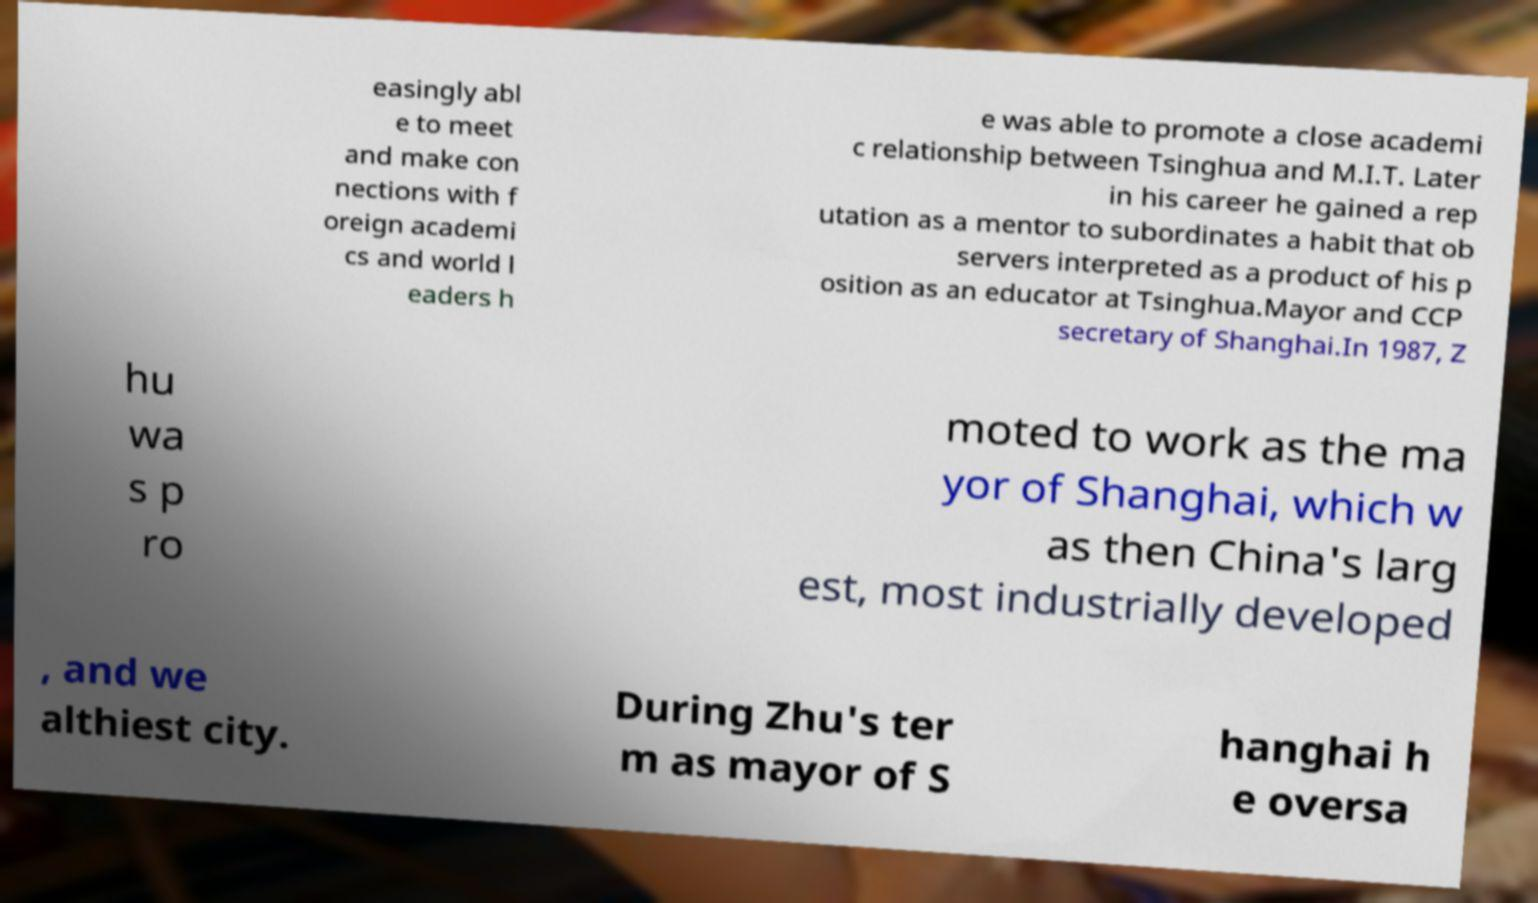Can you accurately transcribe the text from the provided image for me? easingly abl e to meet and make con nections with f oreign academi cs and world l eaders h e was able to promote a close academi c relationship between Tsinghua and M.I.T. Later in his career he gained a rep utation as a mentor to subordinates a habit that ob servers interpreted as a product of his p osition as an educator at Tsinghua.Mayor and CCP secretary of Shanghai.In 1987, Z hu wa s p ro moted to work as the ma yor of Shanghai, which w as then China's larg est, most industrially developed , and we althiest city. During Zhu's ter m as mayor of S hanghai h e oversa 